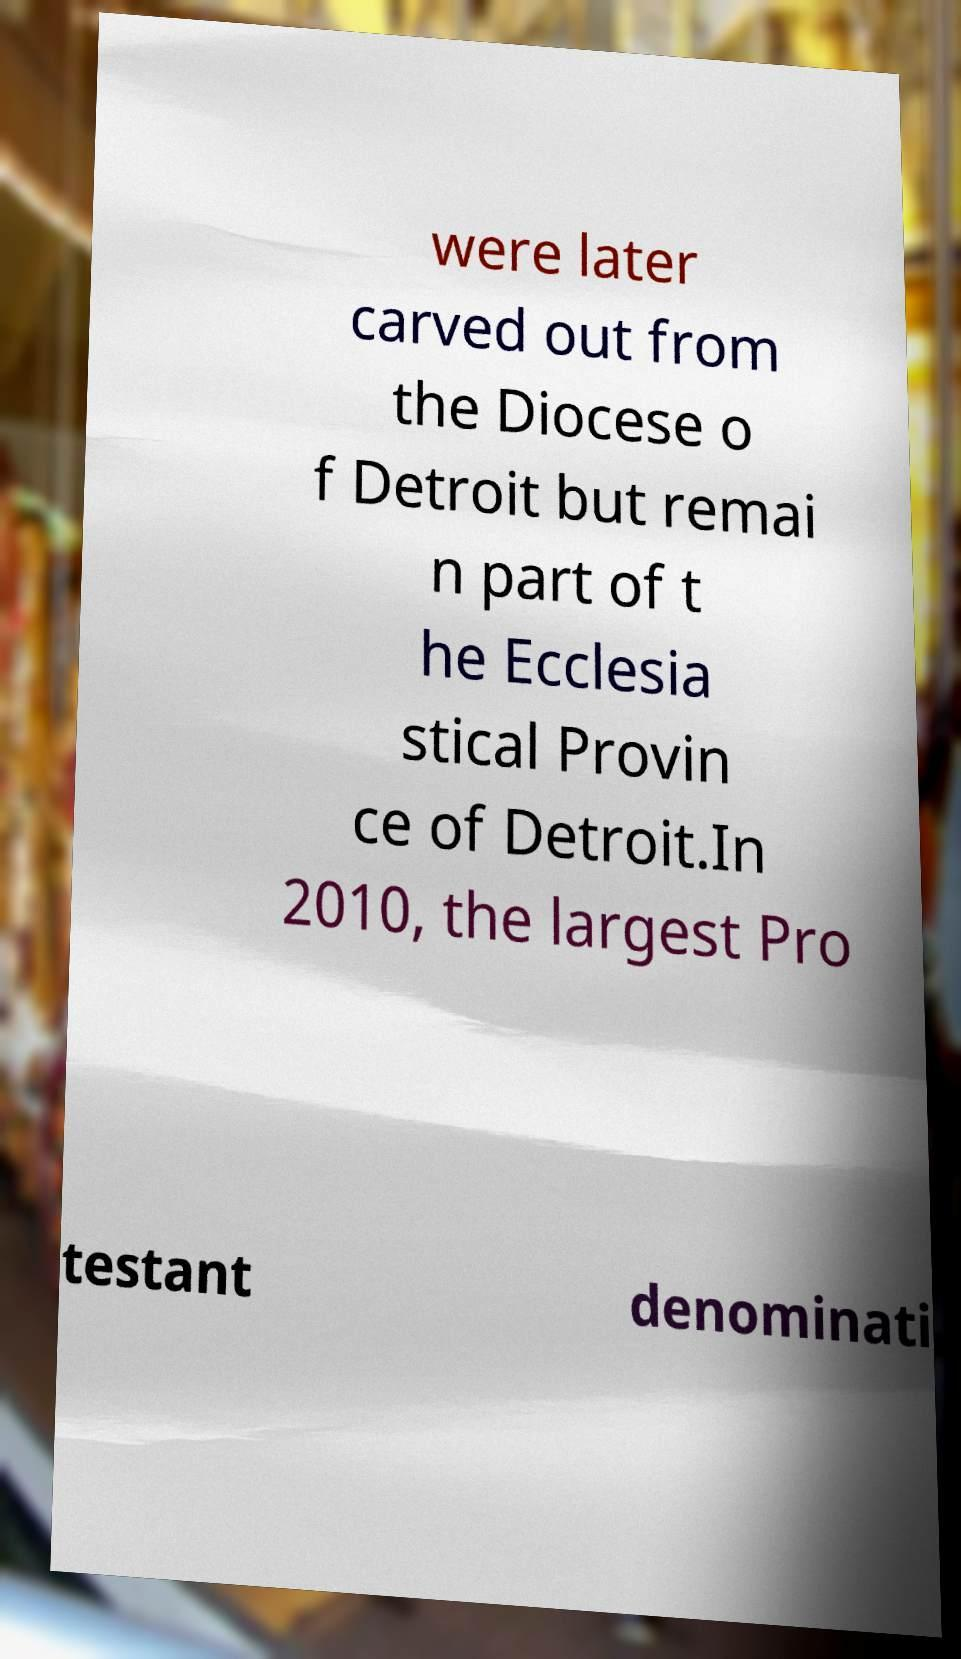Could you extract and type out the text from this image? were later carved out from the Diocese o f Detroit but remai n part of t he Ecclesia stical Provin ce of Detroit.In 2010, the largest Pro testant denominati 